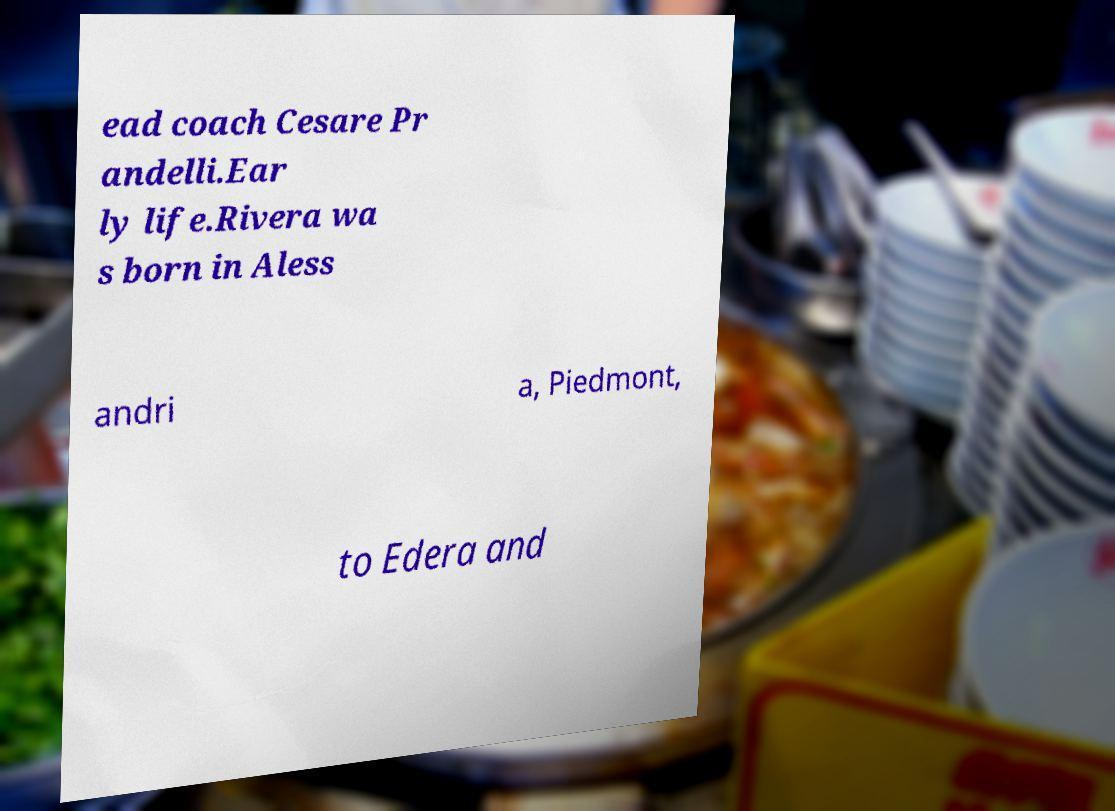For documentation purposes, I need the text within this image transcribed. Could you provide that? ead coach Cesare Pr andelli.Ear ly life.Rivera wa s born in Aless andri a, Piedmont, to Edera and 